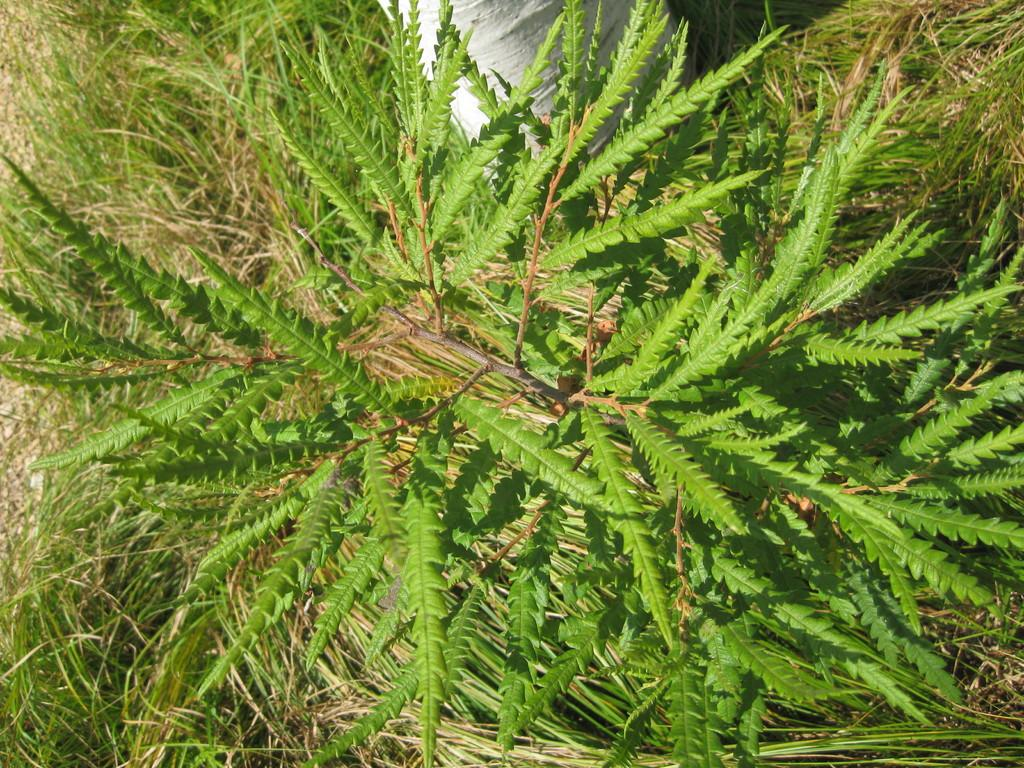What type of vegetation can be seen in the image? There are plants and grass in the image. What is the color of the grass in the image? The grass in the image is green. What can be found in the center of the image? There is a white object in the center of the image. What month is it in the image? The month cannot be determined from the image, as it only shows plants, grass, and a white object. What type of pet can be seen in the image? There are no pets visible in the image. 